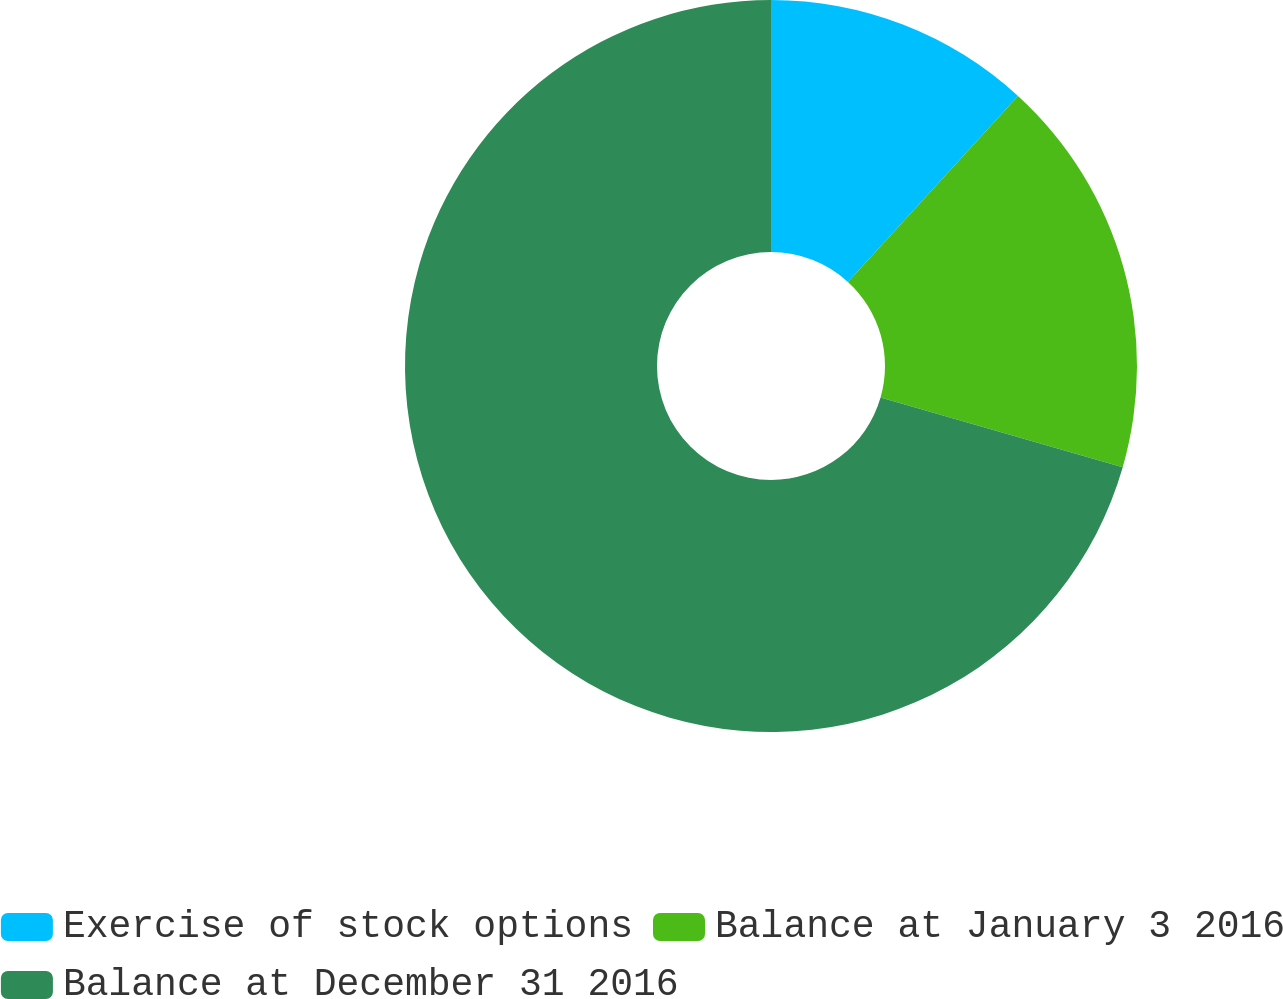Convert chart to OTSL. <chart><loc_0><loc_0><loc_500><loc_500><pie_chart><fcel>Exercise of stock options<fcel>Balance at January 3 2016<fcel>Balance at December 31 2016<nl><fcel>11.79%<fcel>17.67%<fcel>70.54%<nl></chart> 